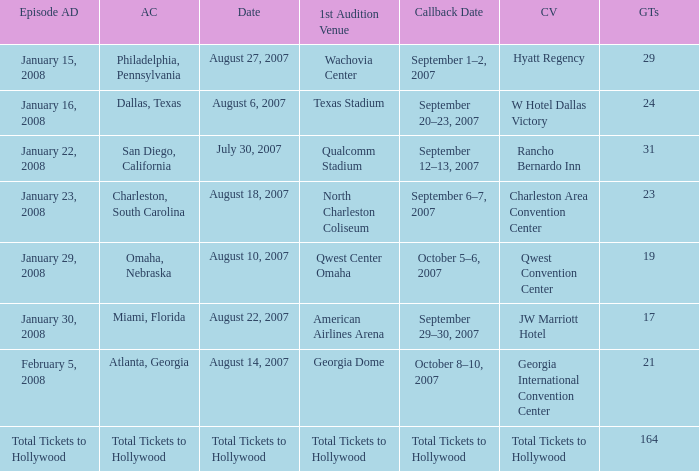What audition city has a Callback Date of october 5–6, 2007? Omaha, Nebraska. 